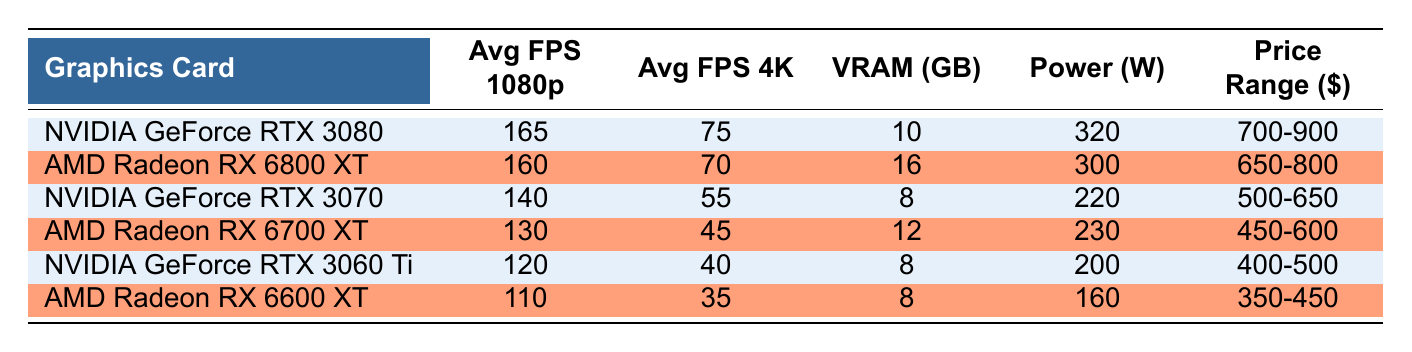What is the average FPS in 1080p for NVIDIA GeForce RTX 3080? The table states that the average FPS in 1080p for NVIDIA GeForce RTX 3080 is 165.
Answer: 165 Which graphics card has the highest VRAM? By comparing the VRAM values, we can see that the AMD Radeon RX 6800 XT has 16 GB, which is the highest among all listed graphics cards.
Answer: AMD Radeon RX 6800 XT What is the difference in average FPS in 4K between RTX 3070 and RTX 3060 Ti? The average FPS in 4K for RTX 3070 is 55, and for RTX 3060 Ti, it is 40. Thus, the difference is 55 - 40 = 15.
Answer: 15 Is the power consumption of AMD Radeon RX 6700 XT higher than that of NVIDIA GeForce RTX 3060 Ti? The power consumption for AMD Radeon RX 6700 XT is 230 watts and for RTX 3060 Ti is 200 watts. Since 230 > 200, the statement is true.
Answer: Yes What is the average frame rate in 1080p for all graphics cards? To find the average, we add the average FPS in 1080p for all graphics cards: 165 + 160 + 140 + 130 + 120 + 110 = 1025. Then, divide by the number of cards (6): 1025 / 6 = approximately 170.83.
Answer: 170.83 